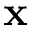Convert formula to latex. <formula><loc_0><loc_0><loc_500><loc_500>x</formula> 